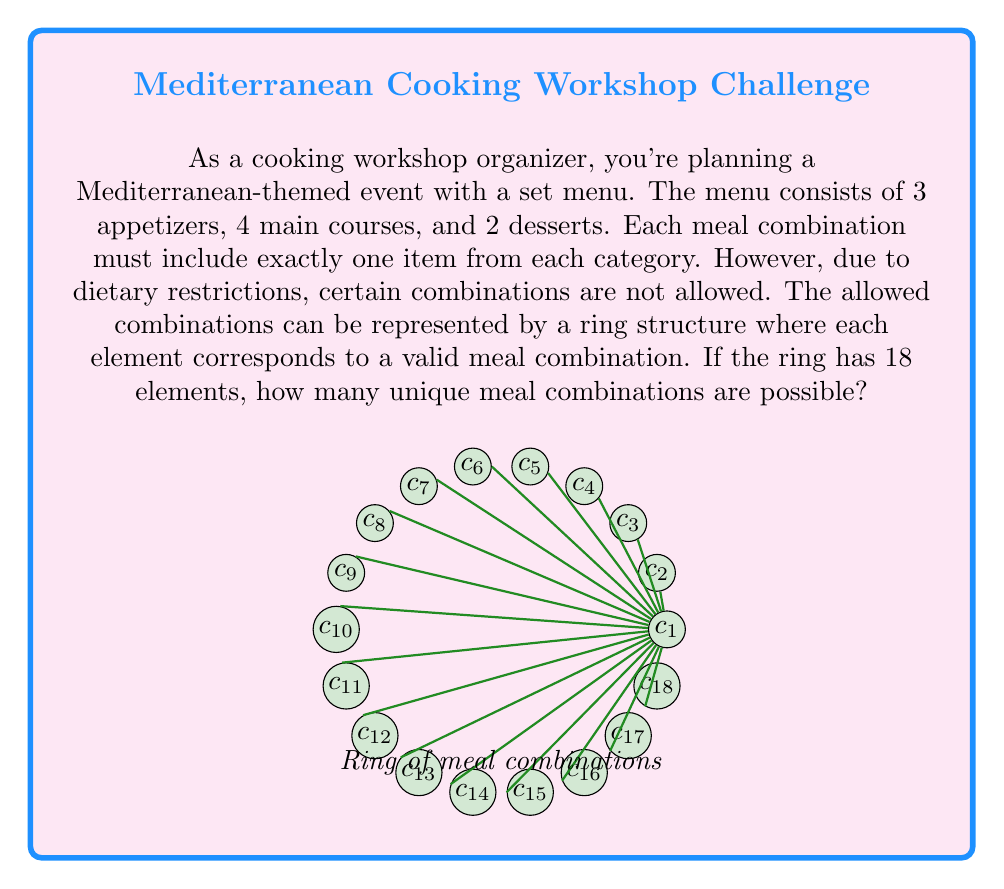Help me with this question. Let's approach this step-by-step:

1) First, let's consider the total possible combinations without restrictions:
   $$3 \text{ appetizers} \times 4 \text{ main courses} \times 2 \text{ desserts} = 24 \text{ combinations}$$

2) However, we're given that the ring structure has 18 elements, each representing a valid meal combination. This means that some combinations are not allowed due to dietary restrictions.

3) In ring theory, the number of elements in a ring represents the order of the ring. Here, the order of the ring is 18.

4) Each element in the ring corresponds to a unique meal combination. Therefore, the number of unique meal combinations is equal to the number of elements in the ring.

5) Since there are 18 elements in the ring, there must be 18 unique meal combinations possible.

6) We can verify this by subtracting the number of restricted combinations from the total:
   $$24 \text{ total combinations} - 6 \text{ restricted combinations} = 18 \text{ valid combinations}$$

This matches the number of elements in our ring structure.
Answer: 18 unique meal combinations 